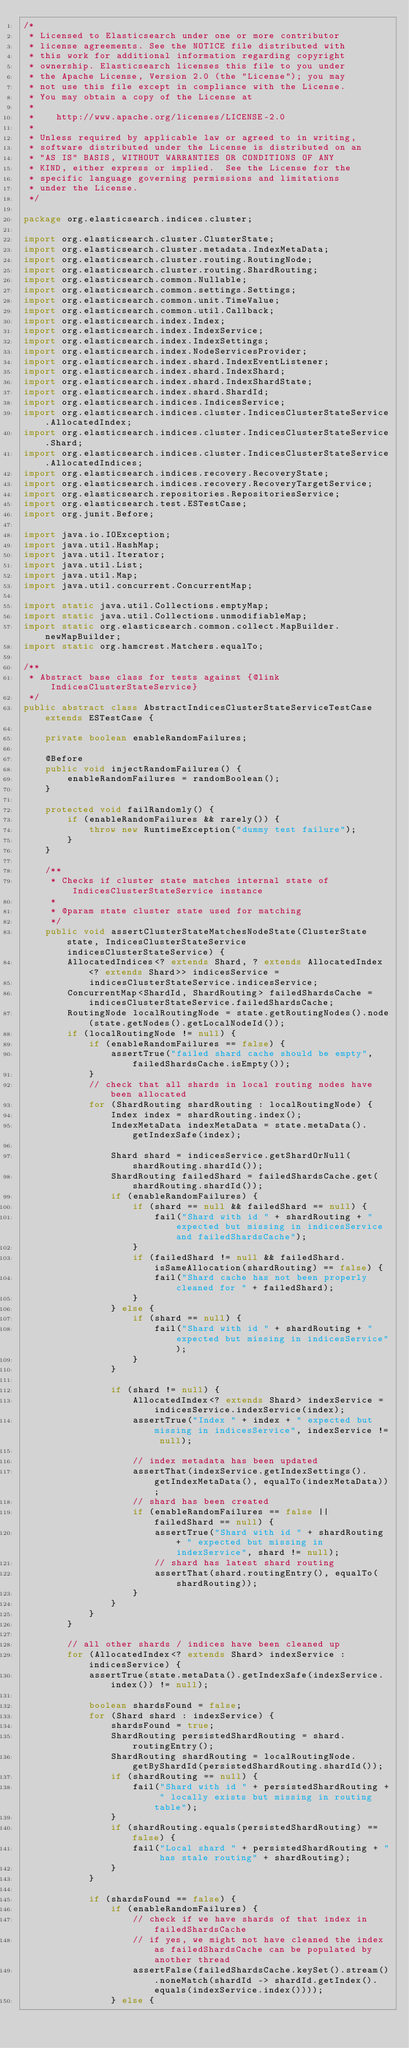Convert code to text. <code><loc_0><loc_0><loc_500><loc_500><_Java_>/*
 * Licensed to Elasticsearch under one or more contributor
 * license agreements. See the NOTICE file distributed with
 * this work for additional information regarding copyright
 * ownership. Elasticsearch licenses this file to you under
 * the Apache License, Version 2.0 (the "License"); you may
 * not use this file except in compliance with the License.
 * You may obtain a copy of the License at
 *
 *    http://www.apache.org/licenses/LICENSE-2.0
 *
 * Unless required by applicable law or agreed to in writing,
 * software distributed under the License is distributed on an
 * "AS IS" BASIS, WITHOUT WARRANTIES OR CONDITIONS OF ANY
 * KIND, either express or implied.  See the License for the
 * specific language governing permissions and limitations
 * under the License.
 */

package org.elasticsearch.indices.cluster;

import org.elasticsearch.cluster.ClusterState;
import org.elasticsearch.cluster.metadata.IndexMetaData;
import org.elasticsearch.cluster.routing.RoutingNode;
import org.elasticsearch.cluster.routing.ShardRouting;
import org.elasticsearch.common.Nullable;
import org.elasticsearch.common.settings.Settings;
import org.elasticsearch.common.unit.TimeValue;
import org.elasticsearch.common.util.Callback;
import org.elasticsearch.index.Index;
import org.elasticsearch.index.IndexService;
import org.elasticsearch.index.IndexSettings;
import org.elasticsearch.index.NodeServicesProvider;
import org.elasticsearch.index.shard.IndexEventListener;
import org.elasticsearch.index.shard.IndexShard;
import org.elasticsearch.index.shard.IndexShardState;
import org.elasticsearch.index.shard.ShardId;
import org.elasticsearch.indices.IndicesService;
import org.elasticsearch.indices.cluster.IndicesClusterStateService.AllocatedIndex;
import org.elasticsearch.indices.cluster.IndicesClusterStateService.Shard;
import org.elasticsearch.indices.cluster.IndicesClusterStateService.AllocatedIndices;
import org.elasticsearch.indices.recovery.RecoveryState;
import org.elasticsearch.indices.recovery.RecoveryTargetService;
import org.elasticsearch.repositories.RepositoriesService;
import org.elasticsearch.test.ESTestCase;
import org.junit.Before;

import java.io.IOException;
import java.util.HashMap;
import java.util.Iterator;
import java.util.List;
import java.util.Map;
import java.util.concurrent.ConcurrentMap;

import static java.util.Collections.emptyMap;
import static java.util.Collections.unmodifiableMap;
import static org.elasticsearch.common.collect.MapBuilder.newMapBuilder;
import static org.hamcrest.Matchers.equalTo;

/**
 * Abstract base class for tests against {@link IndicesClusterStateService}
 */
public abstract class AbstractIndicesClusterStateServiceTestCase extends ESTestCase {

    private boolean enableRandomFailures;

    @Before
    public void injectRandomFailures() {
        enableRandomFailures = randomBoolean();
    }

    protected void failRandomly() {
        if (enableRandomFailures && rarely()) {
            throw new RuntimeException("dummy test failure");
        }
    }

    /**
     * Checks if cluster state matches internal state of IndicesClusterStateService instance
     *
     * @param state cluster state used for matching
     */
    public void assertClusterStateMatchesNodeState(ClusterState state, IndicesClusterStateService indicesClusterStateService) {
        AllocatedIndices<? extends Shard, ? extends AllocatedIndex<? extends Shard>> indicesService =
            indicesClusterStateService.indicesService;
        ConcurrentMap<ShardId, ShardRouting> failedShardsCache = indicesClusterStateService.failedShardsCache;
        RoutingNode localRoutingNode = state.getRoutingNodes().node(state.getNodes().getLocalNodeId());
        if (localRoutingNode != null) {
            if (enableRandomFailures == false) {
                assertTrue("failed shard cache should be empty", failedShardsCache.isEmpty());
            }
            // check that all shards in local routing nodes have been allocated
            for (ShardRouting shardRouting : localRoutingNode) {
                Index index = shardRouting.index();
                IndexMetaData indexMetaData = state.metaData().getIndexSafe(index);

                Shard shard = indicesService.getShardOrNull(shardRouting.shardId());
                ShardRouting failedShard = failedShardsCache.get(shardRouting.shardId());
                if (enableRandomFailures) {
                    if (shard == null && failedShard == null) {
                        fail("Shard with id " + shardRouting + " expected but missing in indicesService and failedShardsCache");
                    }
                    if (failedShard != null && failedShard.isSameAllocation(shardRouting) == false) {
                        fail("Shard cache has not been properly cleaned for " + failedShard);
                    }
                } else {
                    if (shard == null) {
                        fail("Shard with id " + shardRouting + " expected but missing in indicesService");
                    }
                }

                if (shard != null) {
                    AllocatedIndex<? extends Shard> indexService = indicesService.indexService(index);
                    assertTrue("Index " + index + " expected but missing in indicesService", indexService != null);

                    // index metadata has been updated
                    assertThat(indexService.getIndexSettings().getIndexMetaData(), equalTo(indexMetaData));
                    // shard has been created
                    if (enableRandomFailures == false || failedShard == null) {
                        assertTrue("Shard with id " + shardRouting + " expected but missing in indexService", shard != null);
                        // shard has latest shard routing
                        assertThat(shard.routingEntry(), equalTo(shardRouting));
                    }
                }
            }
        }

        // all other shards / indices have been cleaned up
        for (AllocatedIndex<? extends Shard> indexService : indicesService) {
            assertTrue(state.metaData().getIndexSafe(indexService.index()) != null);

            boolean shardsFound = false;
            for (Shard shard : indexService) {
                shardsFound = true;
                ShardRouting persistedShardRouting = shard.routingEntry();
                ShardRouting shardRouting = localRoutingNode.getByShardId(persistedShardRouting.shardId());
                if (shardRouting == null) {
                    fail("Shard with id " + persistedShardRouting + " locally exists but missing in routing table");
                }
                if (shardRouting.equals(persistedShardRouting) == false) {
                    fail("Local shard " + persistedShardRouting + " has stale routing" + shardRouting);
                }
            }

            if (shardsFound == false) {
                if (enableRandomFailures) {
                    // check if we have shards of that index in failedShardsCache
                    // if yes, we might not have cleaned the index as failedShardsCache can be populated by another thread
                    assertFalse(failedShardsCache.keySet().stream().noneMatch(shardId -> shardId.getIndex().equals(indexService.index())));
                } else {</code> 